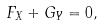<formula> <loc_0><loc_0><loc_500><loc_500>F _ { X } + G _ { Y } = 0 ,</formula> 